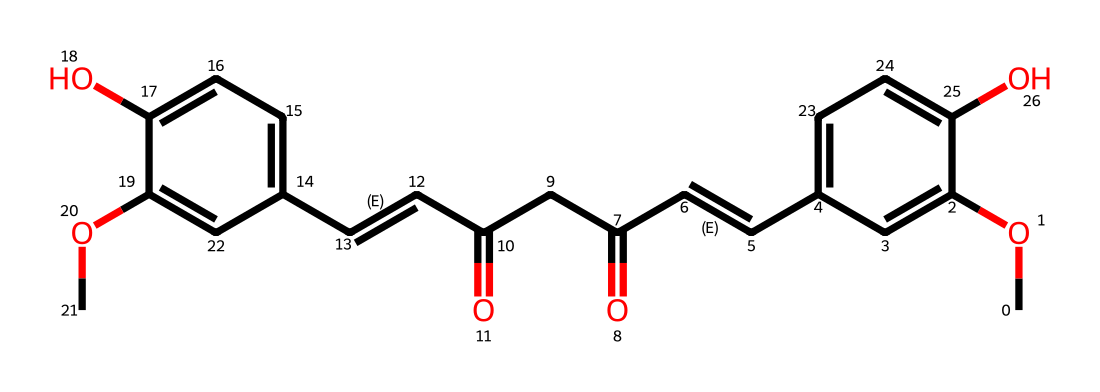What is the molecular formula of curcumin? To find the molecular formula, we need to count the number of each type of atom in the chemical structure. The structure provided shows several carbon (C), hydrogen (H), and oxygen (O) atoms. A careful count reveals there are 21 carbon atoms, 20 hydrogen atoms, and 6 oxygen atoms, resulting in the formula C21H20O6.
Answer: C21H20O6 How many rings are present in the structure of curcumin? By examining the structure closely, we look for rings, which are typically indicated by atoms connected in a circular fashion. The structure contains two phenolic rings, which are recognizable as they include delocalized bonding between carbon atoms. No additional cyclic structures are present, so the total number of rings is 2.
Answer: 2 What functional groups are present in curcumin? Identifying functional groups involves looking for specific structural features like hydroxyl (–OH) groups, carbonyls (C=O), or methoxy groups (–OCH3). In curcumin's structure, there are methoxy groups (indicated by –OCH3), hydroxyl groups (–OH), and carbonyl groups (C=O). The presence of these functional groups contributes to its antioxidant properties.
Answer: methoxy, hydroxyl, carbonyl What is the significance of the double bonds in curcumin? The double bonds in curcumin contribute to its antioxidant activity. Antioxidants typically work by donating electrons to free radicals, stabilizing them. The presence of C=C double bonds increases reactivity, allowing curcumin to effectively engage in electron transfer reactions, which are crucial for its antioxidant mechanism.
Answer: antioxidant activity What type of antioxidant is curcumin classified as? To classify curcumin, we must understand its mechanism. Curcumin acts as a radical scavenger, directly neutralizing free radicals and preventing oxidative stress. Based on this mechanism, curcumin is classified as a phenolic antioxidant due to the presence of hydroxyl groups on its aromatic rings.
Answer: phenolic antioxidant 